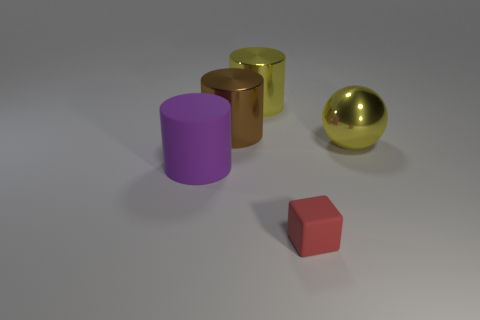Is there another red matte thing that has the same size as the red object?
Provide a short and direct response. No. Are there an equal number of things that are on the left side of the small block and big metallic spheres left of the purple thing?
Offer a very short reply. No. Are the yellow object behind the big yellow metallic sphere and the cylinder in front of the yellow metallic ball made of the same material?
Make the answer very short. No. What is the material of the block?
Your response must be concise. Rubber. How many other objects are the same color as the matte cube?
Give a very brief answer. 0. Is the color of the large ball the same as the big rubber thing?
Make the answer very short. No. How many big yellow shiny things are there?
Keep it short and to the point. 2. The large yellow thing to the right of the big yellow metal object behind the big brown metallic thing is made of what material?
Your response must be concise. Metal. What is the material of the yellow object that is the same size as the metal ball?
Your answer should be compact. Metal. There is a yellow metal object behind the yellow metallic sphere; is its size the same as the big brown metal thing?
Your response must be concise. Yes. 